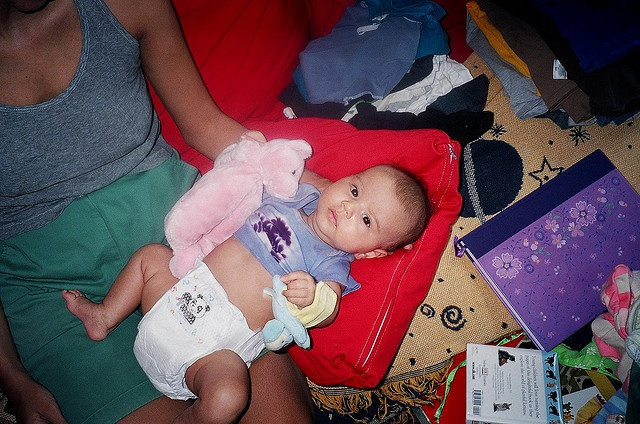Describe the objects in this image and their specific colors. I can see people in black, teal, gray, and maroon tones, people in black, brown, lightpink, lightgray, and darkgray tones, bed in black, tan, and gray tones, book in black, navy, and purple tones, and teddy bear in black, pink, and darkgray tones in this image. 